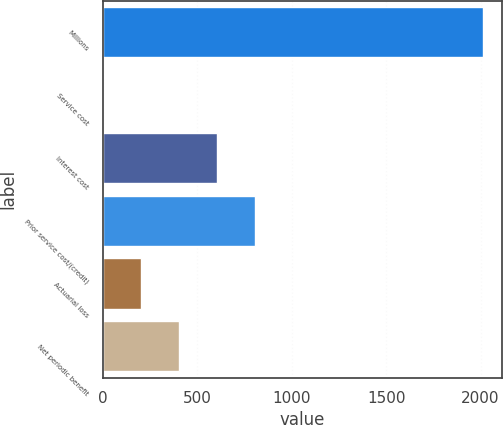Convert chart. <chart><loc_0><loc_0><loc_500><loc_500><bar_chart><fcel>Millions<fcel>Service cost<fcel>Interest cost<fcel>Prior service cost/(credit)<fcel>Actuarial loss<fcel>Net periodic benefit<nl><fcel>2012<fcel>3<fcel>605.7<fcel>806.6<fcel>203.9<fcel>404.8<nl></chart> 